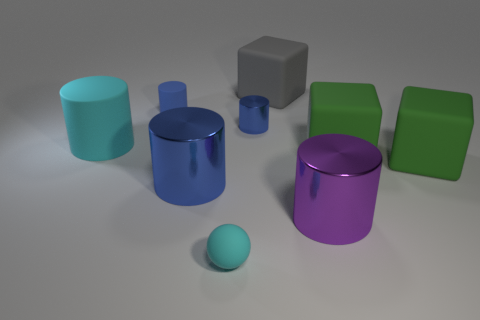What is the size of the purple metal object?
Make the answer very short. Large. Are there fewer small matte balls that are behind the cyan sphere than large shiny things?
Offer a terse response. Yes. Do the cyan rubber cylinder and the purple cylinder have the same size?
Your answer should be compact. Yes. Is there any other thing that has the same size as the sphere?
Make the answer very short. Yes. There is a big cylinder that is the same material as the large blue thing; what is its color?
Keep it short and to the point. Purple. Is the number of large cylinders that are left of the big cyan matte cylinder less than the number of large blue cylinders that are to the left of the small blue matte cylinder?
Make the answer very short. No. How many small shiny cylinders are the same color as the small ball?
Ensure brevity in your answer.  0. There is a big cylinder that is the same color as the small rubber cylinder; what is it made of?
Offer a terse response. Metal. What number of large objects are behind the large blue shiny thing and right of the large blue cylinder?
Provide a succinct answer. 3. What material is the large gray object on the left side of the purple object that is in front of the large cyan matte cylinder made of?
Make the answer very short. Rubber. 